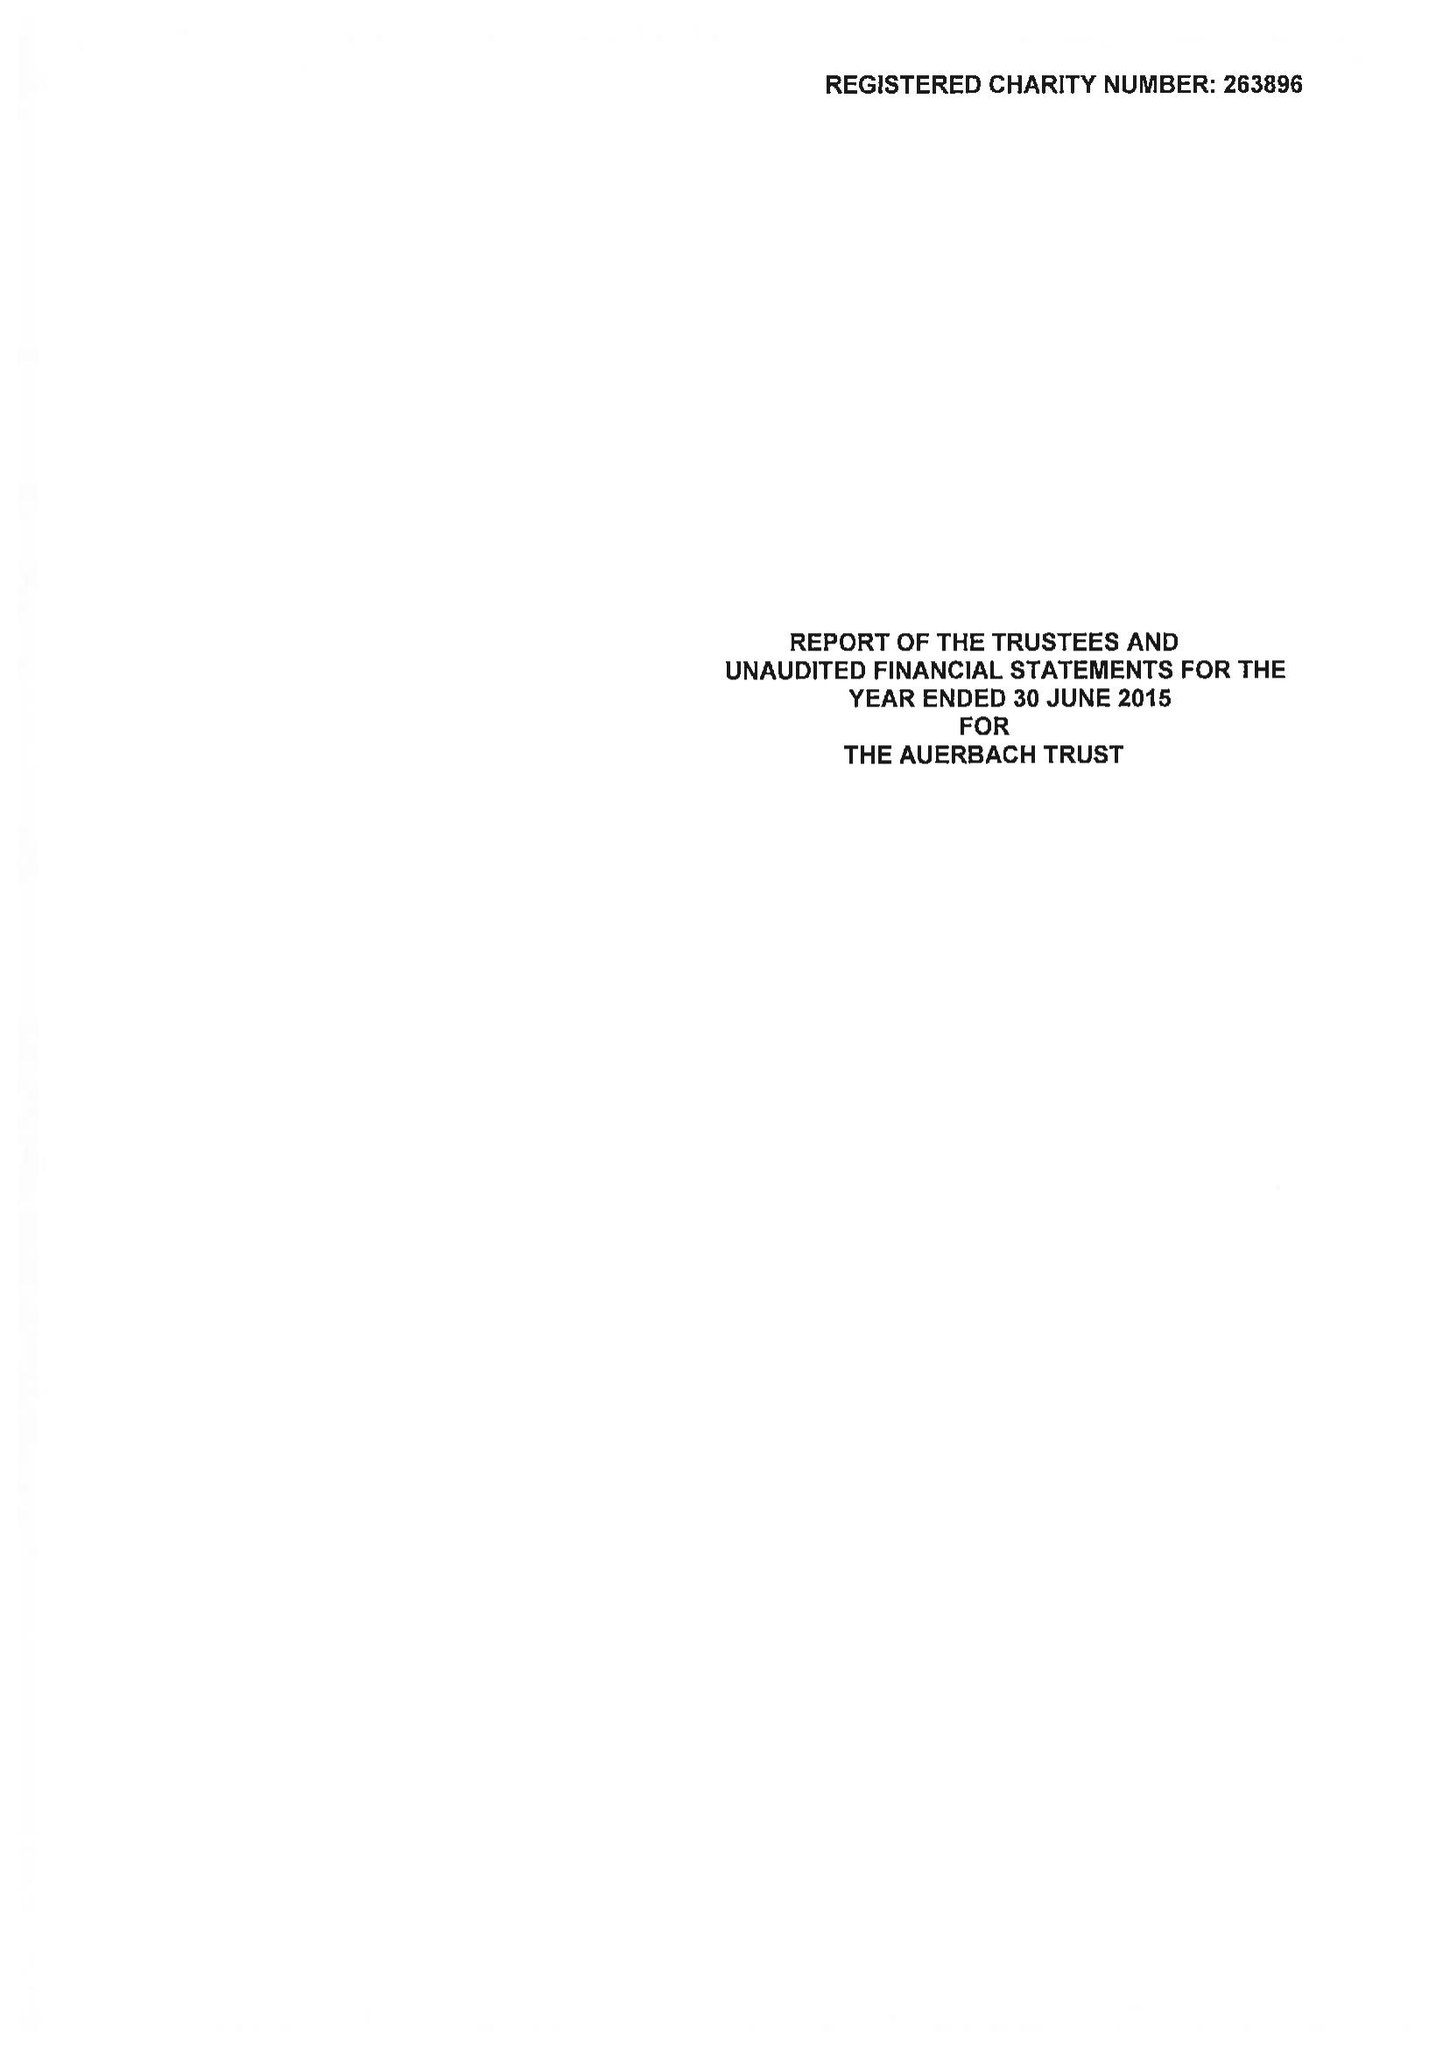What is the value for the address__post_town?
Answer the question using a single word or phrase. LONDON 